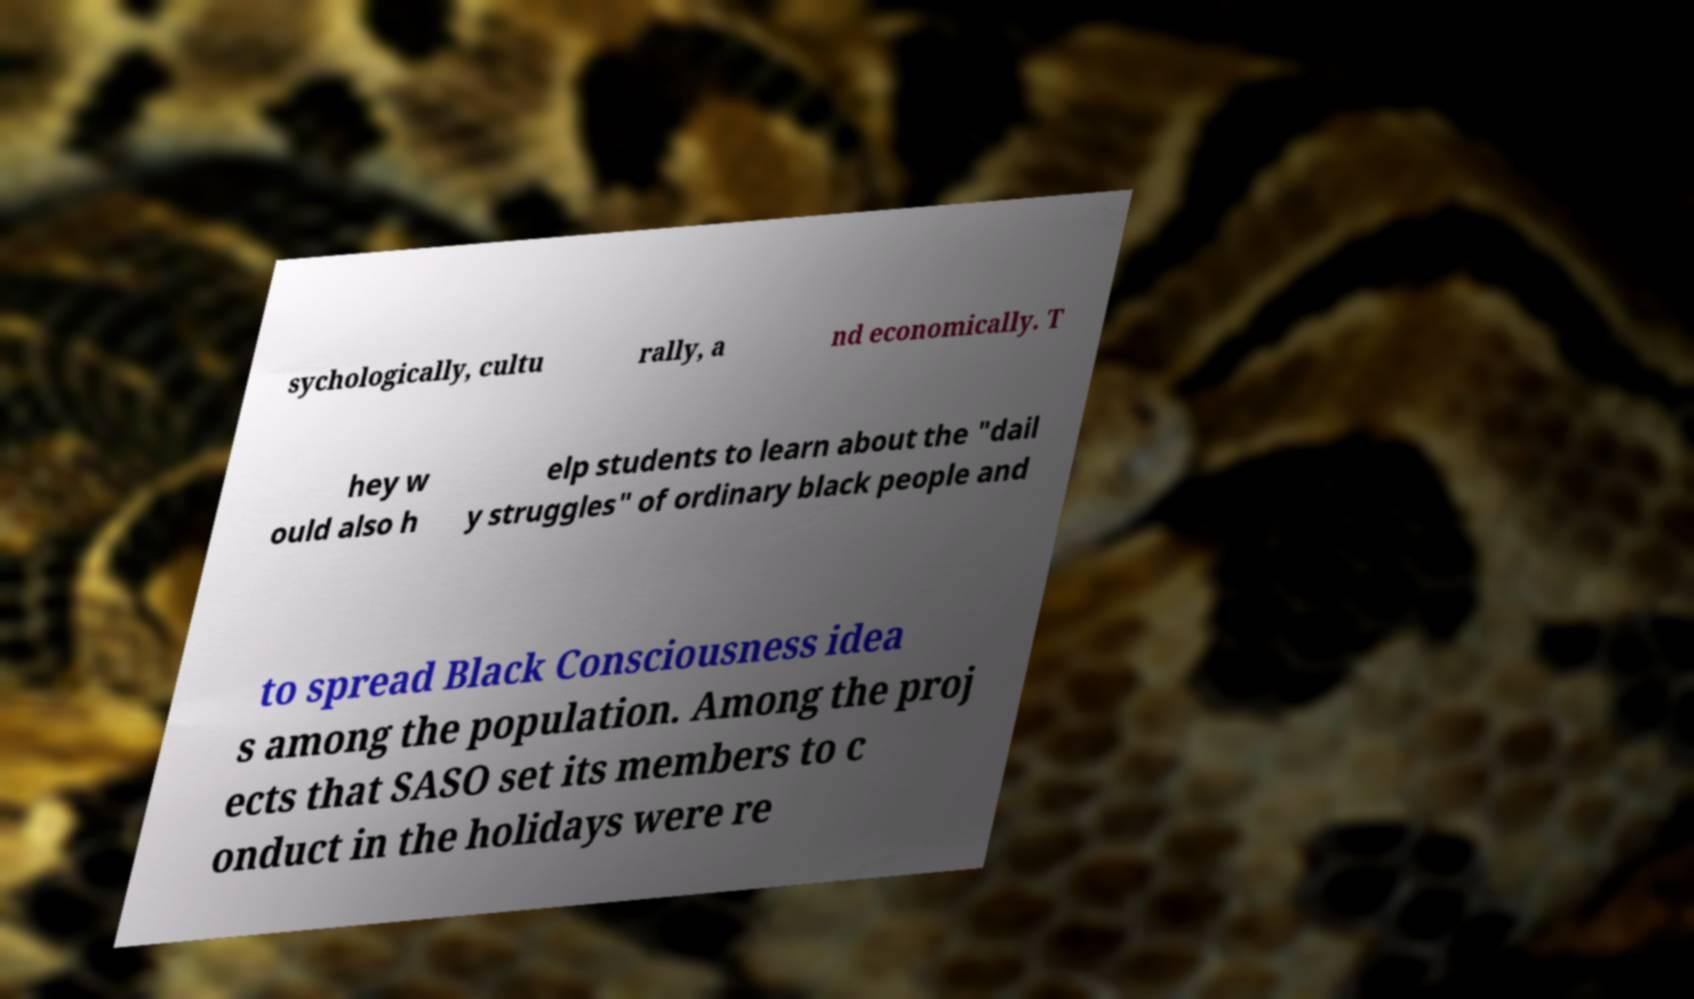There's text embedded in this image that I need extracted. Can you transcribe it verbatim? sychologically, cultu rally, a nd economically. T hey w ould also h elp students to learn about the "dail y struggles" of ordinary black people and to spread Black Consciousness idea s among the population. Among the proj ects that SASO set its members to c onduct in the holidays were re 